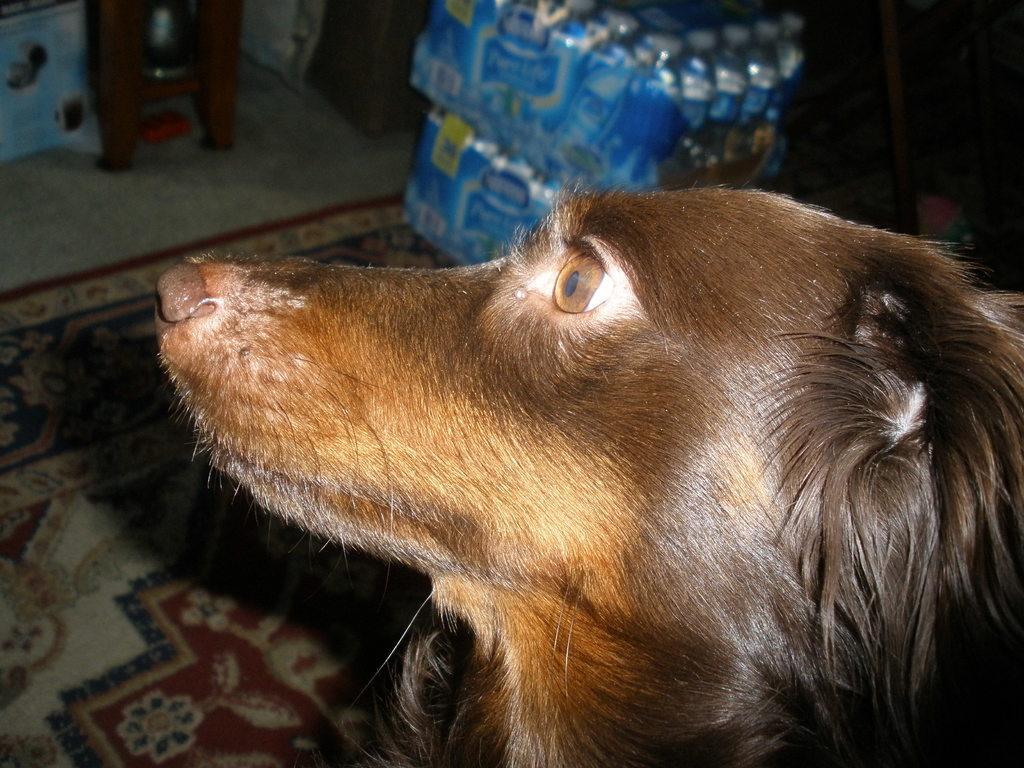How would you summarize this image in a sentence or two? In the image there is a dog and behind the dog there are some set of bottles kept on a carpet. 